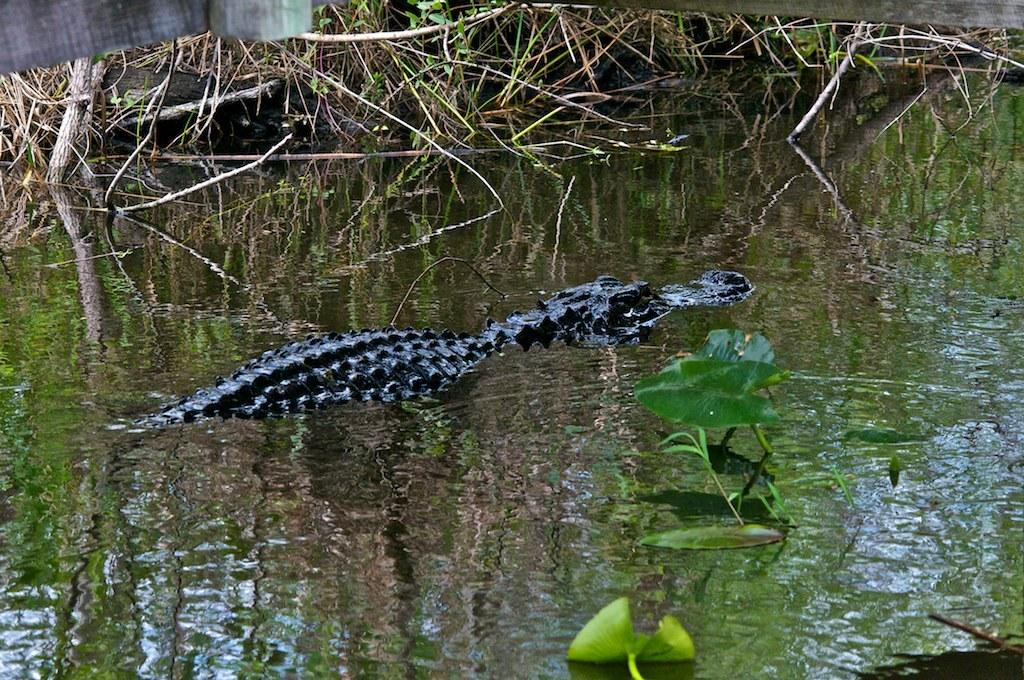What animal can be seen in the image? There is a crocodile in the image. What is the primary element surrounding the crocodile? There is water in the image. What type of vegetation is present in the image? Leaves and branches are visible in the image. How many clocks can be seen hanging from the branches in the image? There are no clocks present in the image; it features a crocodile, water, leaves, and branches. 